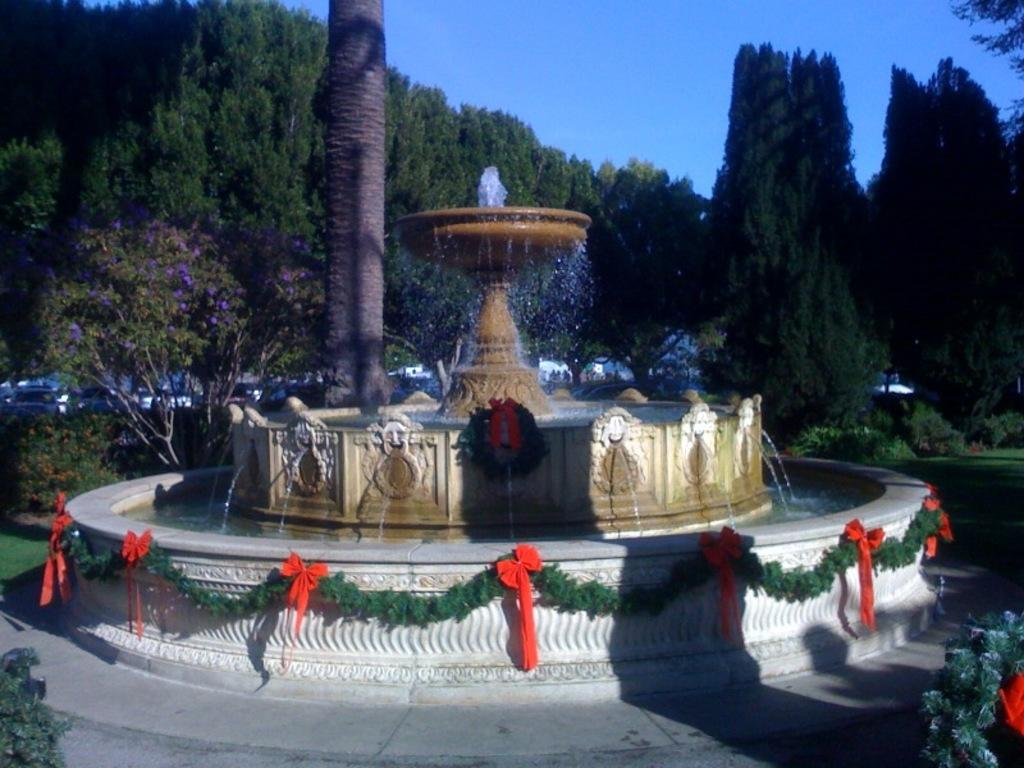What is the main subject of the image? There is a water fountain in the image. How is the water fountain described? The water fountain is described as beautiful. What can be seen near the water fountain? There is a tall tree near the water fountain. What else can be seen in the image besides the water fountain and the tall tree? There are many other trees in the image. What is visible in the background of the image? The sky is visible in the background of the image. What type of feather can be seen floating in the water fountain in the image? There is no feather present in the water fountain in the image. Are there any signs of an attack in the image? There is no indication of an attack in the image. 